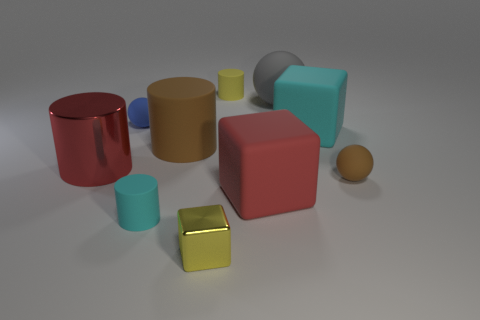Subtract 1 cylinders. How many cylinders are left? 3 Subtract all blocks. How many objects are left? 7 Subtract 0 green cubes. How many objects are left? 10 Subtract all cyan objects. Subtract all matte balls. How many objects are left? 5 Add 9 blue objects. How many blue objects are left? 10 Add 4 large rubber cylinders. How many large rubber cylinders exist? 5 